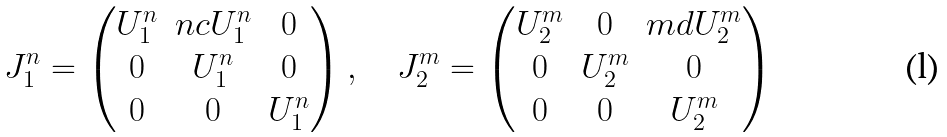<formula> <loc_0><loc_0><loc_500><loc_500>J _ { 1 } ^ { n } = \begin{pmatrix} U _ { 1 } ^ { n } & n c U _ { 1 } ^ { n } & 0 \\ 0 & U _ { 1 } ^ { n } & 0 \\ 0 & 0 & U _ { 1 } ^ { n } \end{pmatrix} , \quad J _ { 2 } ^ { m } = \begin{pmatrix} U _ { 2 } ^ { m } & 0 & m d U _ { 2 } ^ { m } \\ 0 & U _ { 2 } ^ { m } & 0 \\ 0 & 0 & U _ { 2 } ^ { m } \end{pmatrix}</formula> 